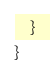<code> <loc_0><loc_0><loc_500><loc_500><_C#_>	}
}
</code> 